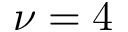<formula> <loc_0><loc_0><loc_500><loc_500>\nu = 4</formula> 